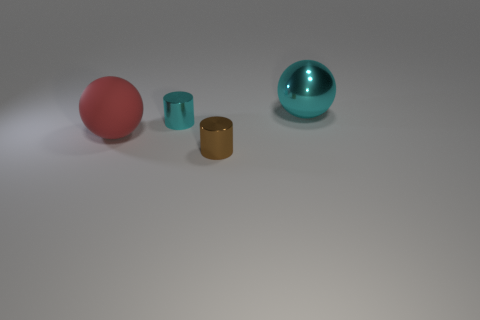What is the material of the large cyan ball?
Make the answer very short. Metal. What shape is the cyan metallic object that is the same size as the red sphere?
Your answer should be compact. Sphere. How many things are things that are in front of the matte thing or spheres in front of the cyan sphere?
Offer a terse response. 2. What material is the thing that is the same size as the brown cylinder?
Give a very brief answer. Metal. What number of other things are made of the same material as the large cyan object?
Offer a terse response. 2. Are there an equal number of red matte things that are behind the tiny cyan metallic cylinder and metallic things in front of the big red ball?
Ensure brevity in your answer.  No. How many brown objects are either cylinders or metal balls?
Ensure brevity in your answer.  1. There is a rubber thing; is it the same color as the metallic cylinder behind the rubber thing?
Your response must be concise. No. How many other things are there of the same color as the big shiny ball?
Your answer should be very brief. 1. Is the number of large red spheres less than the number of tiny metal cylinders?
Ensure brevity in your answer.  Yes. 